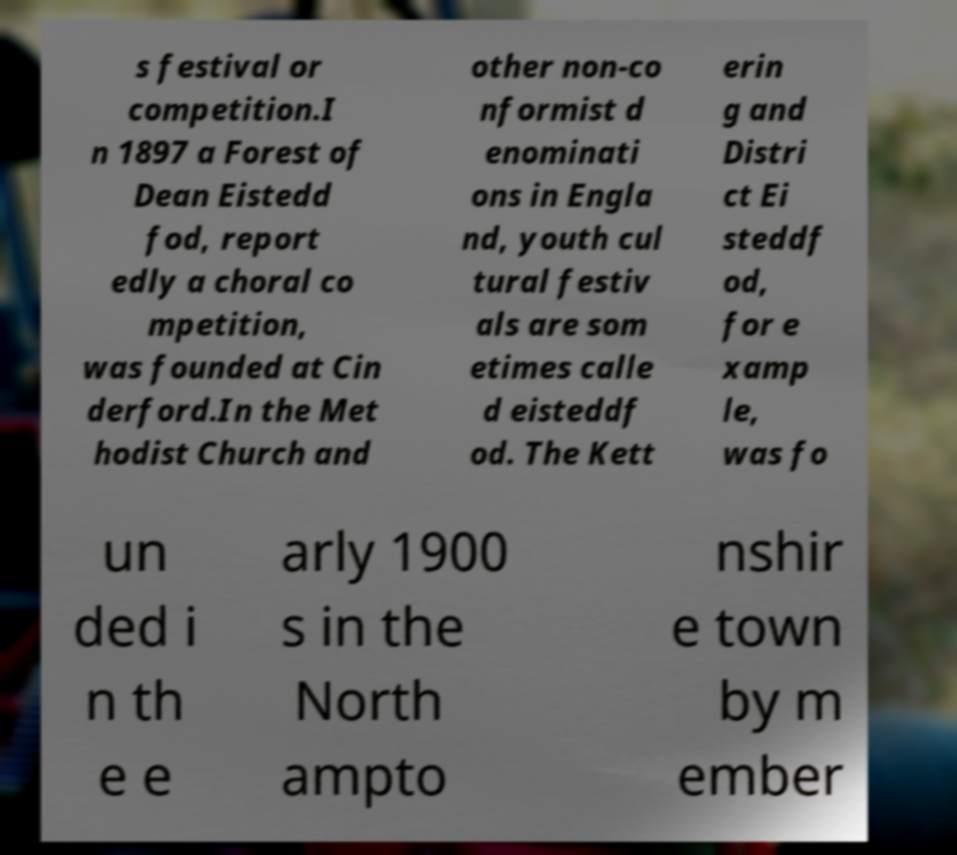For documentation purposes, I need the text within this image transcribed. Could you provide that? s festival or competition.I n 1897 a Forest of Dean Eistedd fod, report edly a choral co mpetition, was founded at Cin derford.In the Met hodist Church and other non-co nformist d enominati ons in Engla nd, youth cul tural festiv als are som etimes calle d eisteddf od. The Kett erin g and Distri ct Ei steddf od, for e xamp le, was fo un ded i n th e e arly 1900 s in the North ampto nshir e town by m ember 